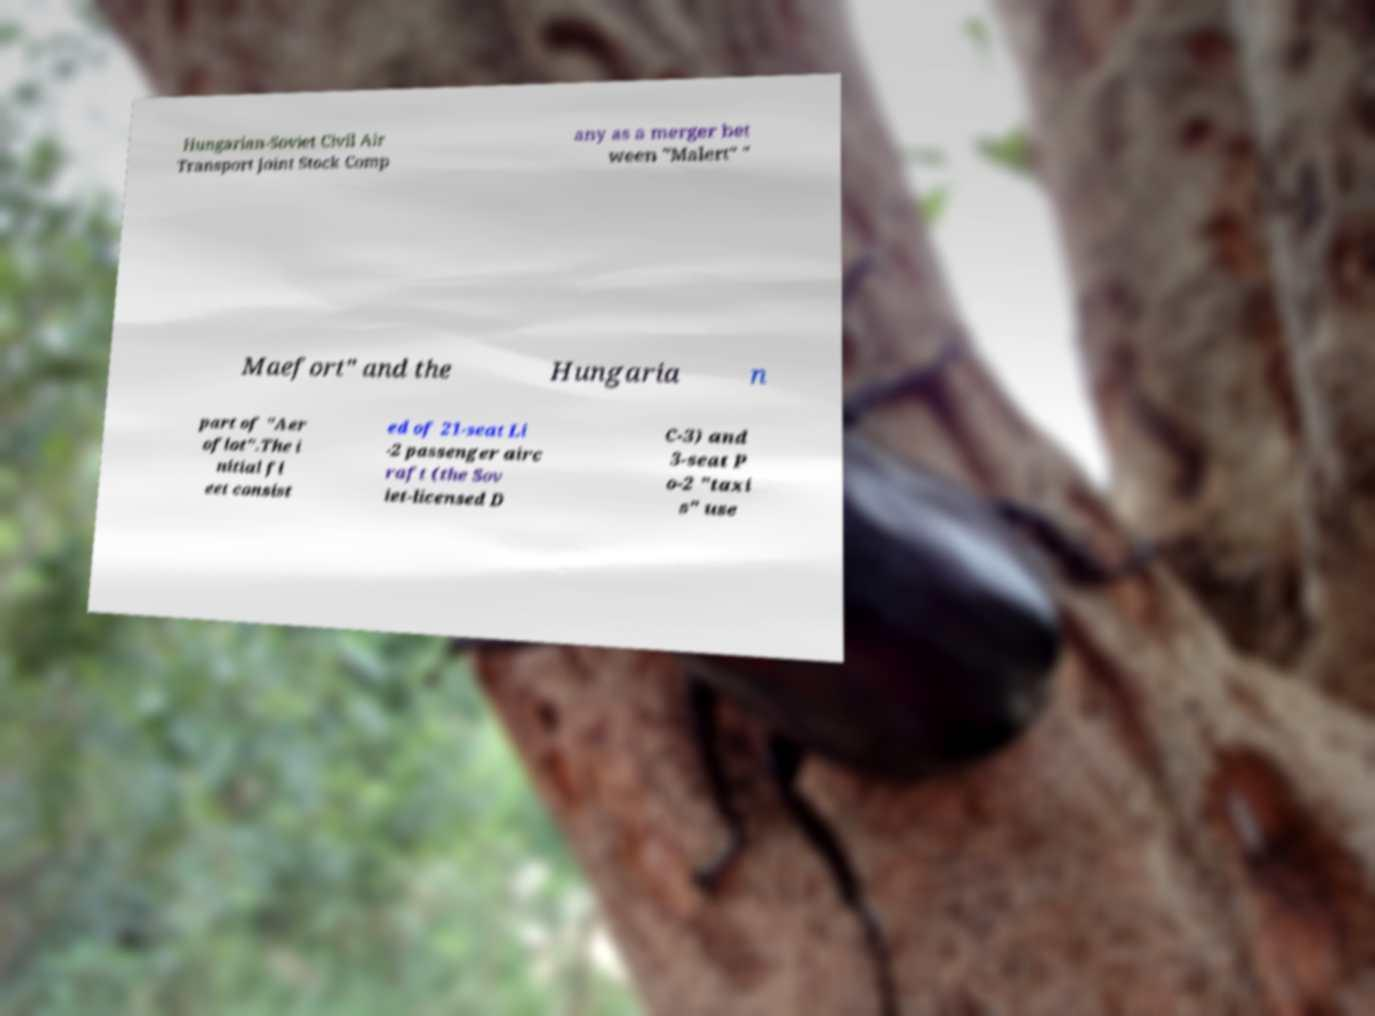There's text embedded in this image that I need extracted. Can you transcribe it verbatim? Hungarian-Soviet Civil Air Transport Joint Stock Comp any as a merger bet ween "Malert" " Maefort" and the Hungaria n part of "Aer oflot".The i nitial fl eet consist ed of 21-seat Li -2 passenger airc raft (the Sov iet-licensed D C-3) and 3-seat P o-2 "taxi s" use 